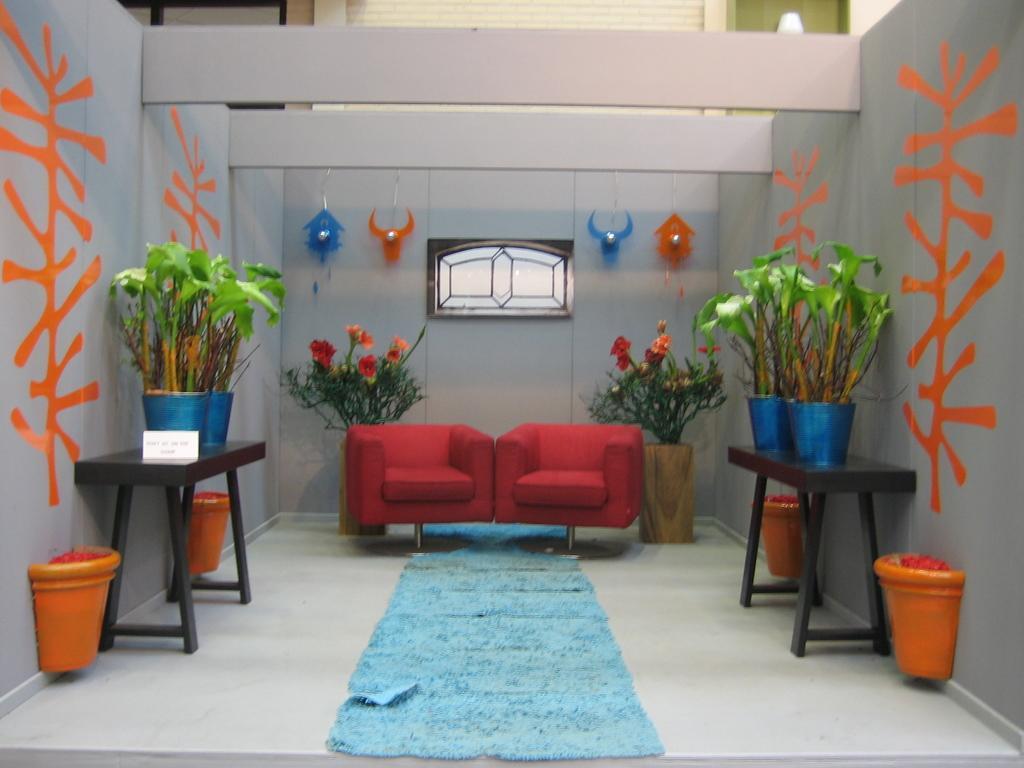Could you give a brief overview of what you see in this image? In this picture there is a sofa set and a blue carpet in front of the sofa. There are some plants placed on the table on either side of this picture. In the background there are some plants and a wall here. 